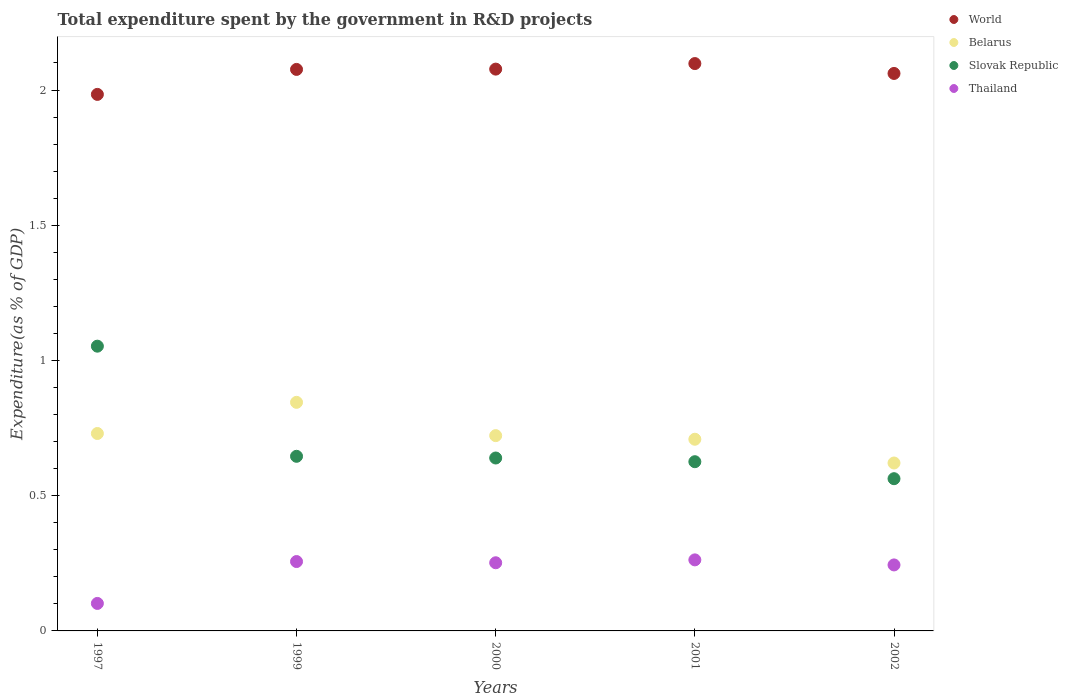What is the total expenditure spent by the government in R&D projects in Thailand in 2002?
Your answer should be very brief. 0.24. Across all years, what is the maximum total expenditure spent by the government in R&D projects in Slovak Republic?
Ensure brevity in your answer.  1.05. Across all years, what is the minimum total expenditure spent by the government in R&D projects in Thailand?
Offer a very short reply. 0.1. In which year was the total expenditure spent by the government in R&D projects in World maximum?
Provide a succinct answer. 2001. What is the total total expenditure spent by the government in R&D projects in World in the graph?
Keep it short and to the point. 10.3. What is the difference between the total expenditure spent by the government in R&D projects in Slovak Republic in 1997 and that in 2000?
Your answer should be very brief. 0.41. What is the difference between the total expenditure spent by the government in R&D projects in Slovak Republic in 2002 and the total expenditure spent by the government in R&D projects in Thailand in 1997?
Ensure brevity in your answer.  0.46. What is the average total expenditure spent by the government in R&D projects in Thailand per year?
Offer a terse response. 0.22. In the year 2000, what is the difference between the total expenditure spent by the government in R&D projects in Belarus and total expenditure spent by the government in R&D projects in Thailand?
Your answer should be compact. 0.47. What is the ratio of the total expenditure spent by the government in R&D projects in Slovak Republic in 1999 to that in 2000?
Give a very brief answer. 1.01. Is the total expenditure spent by the government in R&D projects in Thailand in 1997 less than that in 1999?
Provide a short and direct response. Yes. Is the difference between the total expenditure spent by the government in R&D projects in Belarus in 1999 and 2002 greater than the difference between the total expenditure spent by the government in R&D projects in Thailand in 1999 and 2002?
Ensure brevity in your answer.  Yes. What is the difference between the highest and the second highest total expenditure spent by the government in R&D projects in Thailand?
Provide a succinct answer. 0.01. What is the difference between the highest and the lowest total expenditure spent by the government in R&D projects in World?
Provide a succinct answer. 0.11. In how many years, is the total expenditure spent by the government in R&D projects in Thailand greater than the average total expenditure spent by the government in R&D projects in Thailand taken over all years?
Offer a terse response. 4. Is the sum of the total expenditure spent by the government in R&D projects in World in 1999 and 2001 greater than the maximum total expenditure spent by the government in R&D projects in Thailand across all years?
Give a very brief answer. Yes. Does the total expenditure spent by the government in R&D projects in Slovak Republic monotonically increase over the years?
Give a very brief answer. No. Is the total expenditure spent by the government in R&D projects in Belarus strictly greater than the total expenditure spent by the government in R&D projects in World over the years?
Offer a terse response. No. Is the total expenditure spent by the government in R&D projects in Slovak Republic strictly less than the total expenditure spent by the government in R&D projects in Thailand over the years?
Make the answer very short. No. What is the difference between two consecutive major ticks on the Y-axis?
Your answer should be compact. 0.5. Are the values on the major ticks of Y-axis written in scientific E-notation?
Provide a short and direct response. No. Does the graph contain any zero values?
Your answer should be very brief. No. Where does the legend appear in the graph?
Offer a very short reply. Top right. How many legend labels are there?
Keep it short and to the point. 4. How are the legend labels stacked?
Offer a terse response. Vertical. What is the title of the graph?
Ensure brevity in your answer.  Total expenditure spent by the government in R&D projects. What is the label or title of the X-axis?
Provide a succinct answer. Years. What is the label or title of the Y-axis?
Offer a terse response. Expenditure(as % of GDP). What is the Expenditure(as % of GDP) in World in 1997?
Ensure brevity in your answer.  1.98. What is the Expenditure(as % of GDP) of Belarus in 1997?
Give a very brief answer. 0.73. What is the Expenditure(as % of GDP) of Slovak Republic in 1997?
Your answer should be very brief. 1.05. What is the Expenditure(as % of GDP) in Thailand in 1997?
Your answer should be compact. 0.1. What is the Expenditure(as % of GDP) of World in 1999?
Offer a terse response. 2.08. What is the Expenditure(as % of GDP) in Belarus in 1999?
Provide a short and direct response. 0.85. What is the Expenditure(as % of GDP) in Slovak Republic in 1999?
Ensure brevity in your answer.  0.65. What is the Expenditure(as % of GDP) of Thailand in 1999?
Provide a succinct answer. 0.26. What is the Expenditure(as % of GDP) of World in 2000?
Offer a terse response. 2.08. What is the Expenditure(as % of GDP) in Belarus in 2000?
Provide a succinct answer. 0.72. What is the Expenditure(as % of GDP) in Slovak Republic in 2000?
Your answer should be very brief. 0.64. What is the Expenditure(as % of GDP) in Thailand in 2000?
Ensure brevity in your answer.  0.25. What is the Expenditure(as % of GDP) in World in 2001?
Your answer should be compact. 2.1. What is the Expenditure(as % of GDP) of Belarus in 2001?
Offer a very short reply. 0.71. What is the Expenditure(as % of GDP) of Slovak Republic in 2001?
Your answer should be compact. 0.63. What is the Expenditure(as % of GDP) in Thailand in 2001?
Keep it short and to the point. 0.26. What is the Expenditure(as % of GDP) of World in 2002?
Your response must be concise. 2.06. What is the Expenditure(as % of GDP) of Belarus in 2002?
Make the answer very short. 0.62. What is the Expenditure(as % of GDP) in Slovak Republic in 2002?
Your response must be concise. 0.56. What is the Expenditure(as % of GDP) in Thailand in 2002?
Provide a short and direct response. 0.24. Across all years, what is the maximum Expenditure(as % of GDP) of World?
Your response must be concise. 2.1. Across all years, what is the maximum Expenditure(as % of GDP) of Belarus?
Offer a terse response. 0.85. Across all years, what is the maximum Expenditure(as % of GDP) in Slovak Republic?
Offer a terse response. 1.05. Across all years, what is the maximum Expenditure(as % of GDP) of Thailand?
Your answer should be compact. 0.26. Across all years, what is the minimum Expenditure(as % of GDP) in World?
Your answer should be compact. 1.98. Across all years, what is the minimum Expenditure(as % of GDP) of Belarus?
Offer a very short reply. 0.62. Across all years, what is the minimum Expenditure(as % of GDP) in Slovak Republic?
Ensure brevity in your answer.  0.56. Across all years, what is the minimum Expenditure(as % of GDP) of Thailand?
Your answer should be very brief. 0.1. What is the total Expenditure(as % of GDP) of World in the graph?
Offer a very short reply. 10.3. What is the total Expenditure(as % of GDP) in Belarus in the graph?
Keep it short and to the point. 3.63. What is the total Expenditure(as % of GDP) of Slovak Republic in the graph?
Keep it short and to the point. 3.53. What is the total Expenditure(as % of GDP) in Thailand in the graph?
Make the answer very short. 1.12. What is the difference between the Expenditure(as % of GDP) of World in 1997 and that in 1999?
Offer a terse response. -0.09. What is the difference between the Expenditure(as % of GDP) of Belarus in 1997 and that in 1999?
Provide a succinct answer. -0.12. What is the difference between the Expenditure(as % of GDP) in Slovak Republic in 1997 and that in 1999?
Ensure brevity in your answer.  0.41. What is the difference between the Expenditure(as % of GDP) in Thailand in 1997 and that in 1999?
Your answer should be compact. -0.15. What is the difference between the Expenditure(as % of GDP) in World in 1997 and that in 2000?
Keep it short and to the point. -0.09. What is the difference between the Expenditure(as % of GDP) in Belarus in 1997 and that in 2000?
Give a very brief answer. 0.01. What is the difference between the Expenditure(as % of GDP) of Slovak Republic in 1997 and that in 2000?
Ensure brevity in your answer.  0.41. What is the difference between the Expenditure(as % of GDP) of Thailand in 1997 and that in 2000?
Offer a very short reply. -0.15. What is the difference between the Expenditure(as % of GDP) in World in 1997 and that in 2001?
Offer a very short reply. -0.11. What is the difference between the Expenditure(as % of GDP) of Belarus in 1997 and that in 2001?
Your response must be concise. 0.02. What is the difference between the Expenditure(as % of GDP) in Slovak Republic in 1997 and that in 2001?
Offer a very short reply. 0.43. What is the difference between the Expenditure(as % of GDP) of Thailand in 1997 and that in 2001?
Your response must be concise. -0.16. What is the difference between the Expenditure(as % of GDP) in World in 1997 and that in 2002?
Your answer should be very brief. -0.08. What is the difference between the Expenditure(as % of GDP) of Belarus in 1997 and that in 2002?
Your response must be concise. 0.11. What is the difference between the Expenditure(as % of GDP) of Slovak Republic in 1997 and that in 2002?
Offer a terse response. 0.49. What is the difference between the Expenditure(as % of GDP) in Thailand in 1997 and that in 2002?
Offer a very short reply. -0.14. What is the difference between the Expenditure(as % of GDP) of World in 1999 and that in 2000?
Ensure brevity in your answer.  -0. What is the difference between the Expenditure(as % of GDP) in Belarus in 1999 and that in 2000?
Make the answer very short. 0.12. What is the difference between the Expenditure(as % of GDP) of Slovak Republic in 1999 and that in 2000?
Make the answer very short. 0.01. What is the difference between the Expenditure(as % of GDP) of Thailand in 1999 and that in 2000?
Offer a very short reply. 0. What is the difference between the Expenditure(as % of GDP) in World in 1999 and that in 2001?
Keep it short and to the point. -0.02. What is the difference between the Expenditure(as % of GDP) of Belarus in 1999 and that in 2001?
Keep it short and to the point. 0.14. What is the difference between the Expenditure(as % of GDP) in Slovak Republic in 1999 and that in 2001?
Provide a succinct answer. 0.02. What is the difference between the Expenditure(as % of GDP) in Thailand in 1999 and that in 2001?
Your answer should be very brief. -0.01. What is the difference between the Expenditure(as % of GDP) of World in 1999 and that in 2002?
Provide a short and direct response. 0.01. What is the difference between the Expenditure(as % of GDP) in Belarus in 1999 and that in 2002?
Offer a terse response. 0.22. What is the difference between the Expenditure(as % of GDP) in Slovak Republic in 1999 and that in 2002?
Offer a very short reply. 0.08. What is the difference between the Expenditure(as % of GDP) of Thailand in 1999 and that in 2002?
Offer a very short reply. 0.01. What is the difference between the Expenditure(as % of GDP) of World in 2000 and that in 2001?
Offer a terse response. -0.02. What is the difference between the Expenditure(as % of GDP) of Belarus in 2000 and that in 2001?
Keep it short and to the point. 0.01. What is the difference between the Expenditure(as % of GDP) in Slovak Republic in 2000 and that in 2001?
Ensure brevity in your answer.  0.01. What is the difference between the Expenditure(as % of GDP) of Thailand in 2000 and that in 2001?
Offer a terse response. -0.01. What is the difference between the Expenditure(as % of GDP) of World in 2000 and that in 2002?
Provide a short and direct response. 0.02. What is the difference between the Expenditure(as % of GDP) in Belarus in 2000 and that in 2002?
Ensure brevity in your answer.  0.1. What is the difference between the Expenditure(as % of GDP) in Slovak Republic in 2000 and that in 2002?
Offer a very short reply. 0.08. What is the difference between the Expenditure(as % of GDP) in Thailand in 2000 and that in 2002?
Provide a short and direct response. 0.01. What is the difference between the Expenditure(as % of GDP) of World in 2001 and that in 2002?
Ensure brevity in your answer.  0.04. What is the difference between the Expenditure(as % of GDP) in Belarus in 2001 and that in 2002?
Offer a very short reply. 0.09. What is the difference between the Expenditure(as % of GDP) of Slovak Republic in 2001 and that in 2002?
Your response must be concise. 0.06. What is the difference between the Expenditure(as % of GDP) in Thailand in 2001 and that in 2002?
Make the answer very short. 0.02. What is the difference between the Expenditure(as % of GDP) in World in 1997 and the Expenditure(as % of GDP) in Belarus in 1999?
Your answer should be compact. 1.14. What is the difference between the Expenditure(as % of GDP) of World in 1997 and the Expenditure(as % of GDP) of Slovak Republic in 1999?
Offer a terse response. 1.34. What is the difference between the Expenditure(as % of GDP) of World in 1997 and the Expenditure(as % of GDP) of Thailand in 1999?
Ensure brevity in your answer.  1.73. What is the difference between the Expenditure(as % of GDP) in Belarus in 1997 and the Expenditure(as % of GDP) in Slovak Republic in 1999?
Your answer should be very brief. 0.08. What is the difference between the Expenditure(as % of GDP) in Belarus in 1997 and the Expenditure(as % of GDP) in Thailand in 1999?
Offer a very short reply. 0.47. What is the difference between the Expenditure(as % of GDP) in Slovak Republic in 1997 and the Expenditure(as % of GDP) in Thailand in 1999?
Your answer should be compact. 0.8. What is the difference between the Expenditure(as % of GDP) in World in 1997 and the Expenditure(as % of GDP) in Belarus in 2000?
Provide a succinct answer. 1.26. What is the difference between the Expenditure(as % of GDP) of World in 1997 and the Expenditure(as % of GDP) of Slovak Republic in 2000?
Your response must be concise. 1.34. What is the difference between the Expenditure(as % of GDP) in World in 1997 and the Expenditure(as % of GDP) in Thailand in 2000?
Offer a very short reply. 1.73. What is the difference between the Expenditure(as % of GDP) of Belarus in 1997 and the Expenditure(as % of GDP) of Slovak Republic in 2000?
Your answer should be very brief. 0.09. What is the difference between the Expenditure(as % of GDP) of Belarus in 1997 and the Expenditure(as % of GDP) of Thailand in 2000?
Provide a succinct answer. 0.48. What is the difference between the Expenditure(as % of GDP) of Slovak Republic in 1997 and the Expenditure(as % of GDP) of Thailand in 2000?
Your answer should be compact. 0.8. What is the difference between the Expenditure(as % of GDP) in World in 1997 and the Expenditure(as % of GDP) in Belarus in 2001?
Give a very brief answer. 1.28. What is the difference between the Expenditure(as % of GDP) in World in 1997 and the Expenditure(as % of GDP) in Slovak Republic in 2001?
Make the answer very short. 1.36. What is the difference between the Expenditure(as % of GDP) of World in 1997 and the Expenditure(as % of GDP) of Thailand in 2001?
Ensure brevity in your answer.  1.72. What is the difference between the Expenditure(as % of GDP) of Belarus in 1997 and the Expenditure(as % of GDP) of Slovak Republic in 2001?
Offer a very short reply. 0.1. What is the difference between the Expenditure(as % of GDP) in Belarus in 1997 and the Expenditure(as % of GDP) in Thailand in 2001?
Give a very brief answer. 0.47. What is the difference between the Expenditure(as % of GDP) of Slovak Republic in 1997 and the Expenditure(as % of GDP) of Thailand in 2001?
Provide a short and direct response. 0.79. What is the difference between the Expenditure(as % of GDP) in World in 1997 and the Expenditure(as % of GDP) in Belarus in 2002?
Make the answer very short. 1.36. What is the difference between the Expenditure(as % of GDP) in World in 1997 and the Expenditure(as % of GDP) in Slovak Republic in 2002?
Your response must be concise. 1.42. What is the difference between the Expenditure(as % of GDP) of World in 1997 and the Expenditure(as % of GDP) of Thailand in 2002?
Your response must be concise. 1.74. What is the difference between the Expenditure(as % of GDP) in Belarus in 1997 and the Expenditure(as % of GDP) in Slovak Republic in 2002?
Your response must be concise. 0.17. What is the difference between the Expenditure(as % of GDP) in Belarus in 1997 and the Expenditure(as % of GDP) in Thailand in 2002?
Ensure brevity in your answer.  0.49. What is the difference between the Expenditure(as % of GDP) in Slovak Republic in 1997 and the Expenditure(as % of GDP) in Thailand in 2002?
Offer a terse response. 0.81. What is the difference between the Expenditure(as % of GDP) of World in 1999 and the Expenditure(as % of GDP) of Belarus in 2000?
Offer a terse response. 1.35. What is the difference between the Expenditure(as % of GDP) of World in 1999 and the Expenditure(as % of GDP) of Slovak Republic in 2000?
Keep it short and to the point. 1.44. What is the difference between the Expenditure(as % of GDP) in World in 1999 and the Expenditure(as % of GDP) in Thailand in 2000?
Offer a terse response. 1.82. What is the difference between the Expenditure(as % of GDP) of Belarus in 1999 and the Expenditure(as % of GDP) of Slovak Republic in 2000?
Provide a short and direct response. 0.21. What is the difference between the Expenditure(as % of GDP) of Belarus in 1999 and the Expenditure(as % of GDP) of Thailand in 2000?
Provide a short and direct response. 0.59. What is the difference between the Expenditure(as % of GDP) of Slovak Republic in 1999 and the Expenditure(as % of GDP) of Thailand in 2000?
Provide a succinct answer. 0.39. What is the difference between the Expenditure(as % of GDP) of World in 1999 and the Expenditure(as % of GDP) of Belarus in 2001?
Offer a very short reply. 1.37. What is the difference between the Expenditure(as % of GDP) of World in 1999 and the Expenditure(as % of GDP) of Slovak Republic in 2001?
Offer a terse response. 1.45. What is the difference between the Expenditure(as % of GDP) of World in 1999 and the Expenditure(as % of GDP) of Thailand in 2001?
Ensure brevity in your answer.  1.81. What is the difference between the Expenditure(as % of GDP) of Belarus in 1999 and the Expenditure(as % of GDP) of Slovak Republic in 2001?
Give a very brief answer. 0.22. What is the difference between the Expenditure(as % of GDP) in Belarus in 1999 and the Expenditure(as % of GDP) in Thailand in 2001?
Offer a very short reply. 0.58. What is the difference between the Expenditure(as % of GDP) in Slovak Republic in 1999 and the Expenditure(as % of GDP) in Thailand in 2001?
Your answer should be compact. 0.38. What is the difference between the Expenditure(as % of GDP) of World in 1999 and the Expenditure(as % of GDP) of Belarus in 2002?
Offer a very short reply. 1.46. What is the difference between the Expenditure(as % of GDP) of World in 1999 and the Expenditure(as % of GDP) of Slovak Republic in 2002?
Offer a very short reply. 1.51. What is the difference between the Expenditure(as % of GDP) in World in 1999 and the Expenditure(as % of GDP) in Thailand in 2002?
Give a very brief answer. 1.83. What is the difference between the Expenditure(as % of GDP) in Belarus in 1999 and the Expenditure(as % of GDP) in Slovak Republic in 2002?
Provide a short and direct response. 0.28. What is the difference between the Expenditure(as % of GDP) in Belarus in 1999 and the Expenditure(as % of GDP) in Thailand in 2002?
Keep it short and to the point. 0.6. What is the difference between the Expenditure(as % of GDP) of Slovak Republic in 1999 and the Expenditure(as % of GDP) of Thailand in 2002?
Your answer should be very brief. 0.4. What is the difference between the Expenditure(as % of GDP) of World in 2000 and the Expenditure(as % of GDP) of Belarus in 2001?
Make the answer very short. 1.37. What is the difference between the Expenditure(as % of GDP) in World in 2000 and the Expenditure(as % of GDP) in Slovak Republic in 2001?
Your answer should be compact. 1.45. What is the difference between the Expenditure(as % of GDP) in World in 2000 and the Expenditure(as % of GDP) in Thailand in 2001?
Give a very brief answer. 1.81. What is the difference between the Expenditure(as % of GDP) in Belarus in 2000 and the Expenditure(as % of GDP) in Slovak Republic in 2001?
Your response must be concise. 0.1. What is the difference between the Expenditure(as % of GDP) in Belarus in 2000 and the Expenditure(as % of GDP) in Thailand in 2001?
Offer a terse response. 0.46. What is the difference between the Expenditure(as % of GDP) in Slovak Republic in 2000 and the Expenditure(as % of GDP) in Thailand in 2001?
Give a very brief answer. 0.38. What is the difference between the Expenditure(as % of GDP) in World in 2000 and the Expenditure(as % of GDP) in Belarus in 2002?
Your answer should be very brief. 1.46. What is the difference between the Expenditure(as % of GDP) of World in 2000 and the Expenditure(as % of GDP) of Slovak Republic in 2002?
Make the answer very short. 1.51. What is the difference between the Expenditure(as % of GDP) of World in 2000 and the Expenditure(as % of GDP) of Thailand in 2002?
Offer a very short reply. 1.83. What is the difference between the Expenditure(as % of GDP) of Belarus in 2000 and the Expenditure(as % of GDP) of Slovak Republic in 2002?
Offer a very short reply. 0.16. What is the difference between the Expenditure(as % of GDP) in Belarus in 2000 and the Expenditure(as % of GDP) in Thailand in 2002?
Ensure brevity in your answer.  0.48. What is the difference between the Expenditure(as % of GDP) in Slovak Republic in 2000 and the Expenditure(as % of GDP) in Thailand in 2002?
Make the answer very short. 0.4. What is the difference between the Expenditure(as % of GDP) in World in 2001 and the Expenditure(as % of GDP) in Belarus in 2002?
Give a very brief answer. 1.48. What is the difference between the Expenditure(as % of GDP) in World in 2001 and the Expenditure(as % of GDP) in Slovak Republic in 2002?
Provide a succinct answer. 1.53. What is the difference between the Expenditure(as % of GDP) in World in 2001 and the Expenditure(as % of GDP) in Thailand in 2002?
Offer a very short reply. 1.85. What is the difference between the Expenditure(as % of GDP) of Belarus in 2001 and the Expenditure(as % of GDP) of Slovak Republic in 2002?
Keep it short and to the point. 0.15. What is the difference between the Expenditure(as % of GDP) of Belarus in 2001 and the Expenditure(as % of GDP) of Thailand in 2002?
Provide a succinct answer. 0.46. What is the difference between the Expenditure(as % of GDP) in Slovak Republic in 2001 and the Expenditure(as % of GDP) in Thailand in 2002?
Offer a terse response. 0.38. What is the average Expenditure(as % of GDP) of World per year?
Offer a very short reply. 2.06. What is the average Expenditure(as % of GDP) in Belarus per year?
Provide a short and direct response. 0.73. What is the average Expenditure(as % of GDP) in Slovak Republic per year?
Make the answer very short. 0.71. What is the average Expenditure(as % of GDP) of Thailand per year?
Your response must be concise. 0.22. In the year 1997, what is the difference between the Expenditure(as % of GDP) of World and Expenditure(as % of GDP) of Belarus?
Offer a terse response. 1.25. In the year 1997, what is the difference between the Expenditure(as % of GDP) of World and Expenditure(as % of GDP) of Thailand?
Give a very brief answer. 1.88. In the year 1997, what is the difference between the Expenditure(as % of GDP) of Belarus and Expenditure(as % of GDP) of Slovak Republic?
Provide a succinct answer. -0.32. In the year 1997, what is the difference between the Expenditure(as % of GDP) of Belarus and Expenditure(as % of GDP) of Thailand?
Keep it short and to the point. 0.63. In the year 1997, what is the difference between the Expenditure(as % of GDP) of Slovak Republic and Expenditure(as % of GDP) of Thailand?
Ensure brevity in your answer.  0.95. In the year 1999, what is the difference between the Expenditure(as % of GDP) of World and Expenditure(as % of GDP) of Belarus?
Offer a terse response. 1.23. In the year 1999, what is the difference between the Expenditure(as % of GDP) of World and Expenditure(as % of GDP) of Slovak Republic?
Keep it short and to the point. 1.43. In the year 1999, what is the difference between the Expenditure(as % of GDP) of World and Expenditure(as % of GDP) of Thailand?
Your answer should be very brief. 1.82. In the year 1999, what is the difference between the Expenditure(as % of GDP) in Belarus and Expenditure(as % of GDP) in Slovak Republic?
Offer a very short reply. 0.2. In the year 1999, what is the difference between the Expenditure(as % of GDP) of Belarus and Expenditure(as % of GDP) of Thailand?
Your answer should be very brief. 0.59. In the year 1999, what is the difference between the Expenditure(as % of GDP) in Slovak Republic and Expenditure(as % of GDP) in Thailand?
Your answer should be compact. 0.39. In the year 2000, what is the difference between the Expenditure(as % of GDP) of World and Expenditure(as % of GDP) of Belarus?
Your answer should be compact. 1.36. In the year 2000, what is the difference between the Expenditure(as % of GDP) in World and Expenditure(as % of GDP) in Slovak Republic?
Provide a succinct answer. 1.44. In the year 2000, what is the difference between the Expenditure(as % of GDP) in World and Expenditure(as % of GDP) in Thailand?
Give a very brief answer. 1.83. In the year 2000, what is the difference between the Expenditure(as % of GDP) of Belarus and Expenditure(as % of GDP) of Slovak Republic?
Ensure brevity in your answer.  0.08. In the year 2000, what is the difference between the Expenditure(as % of GDP) of Belarus and Expenditure(as % of GDP) of Thailand?
Provide a short and direct response. 0.47. In the year 2000, what is the difference between the Expenditure(as % of GDP) in Slovak Republic and Expenditure(as % of GDP) in Thailand?
Give a very brief answer. 0.39. In the year 2001, what is the difference between the Expenditure(as % of GDP) in World and Expenditure(as % of GDP) in Belarus?
Your answer should be very brief. 1.39. In the year 2001, what is the difference between the Expenditure(as % of GDP) in World and Expenditure(as % of GDP) in Slovak Republic?
Provide a short and direct response. 1.47. In the year 2001, what is the difference between the Expenditure(as % of GDP) of World and Expenditure(as % of GDP) of Thailand?
Offer a terse response. 1.84. In the year 2001, what is the difference between the Expenditure(as % of GDP) of Belarus and Expenditure(as % of GDP) of Slovak Republic?
Your response must be concise. 0.08. In the year 2001, what is the difference between the Expenditure(as % of GDP) in Belarus and Expenditure(as % of GDP) in Thailand?
Give a very brief answer. 0.45. In the year 2001, what is the difference between the Expenditure(as % of GDP) in Slovak Republic and Expenditure(as % of GDP) in Thailand?
Offer a terse response. 0.36. In the year 2002, what is the difference between the Expenditure(as % of GDP) in World and Expenditure(as % of GDP) in Belarus?
Provide a succinct answer. 1.44. In the year 2002, what is the difference between the Expenditure(as % of GDP) of World and Expenditure(as % of GDP) of Slovak Republic?
Your answer should be compact. 1.5. In the year 2002, what is the difference between the Expenditure(as % of GDP) in World and Expenditure(as % of GDP) in Thailand?
Your answer should be very brief. 1.82. In the year 2002, what is the difference between the Expenditure(as % of GDP) in Belarus and Expenditure(as % of GDP) in Slovak Republic?
Ensure brevity in your answer.  0.06. In the year 2002, what is the difference between the Expenditure(as % of GDP) of Belarus and Expenditure(as % of GDP) of Thailand?
Provide a short and direct response. 0.38. In the year 2002, what is the difference between the Expenditure(as % of GDP) of Slovak Republic and Expenditure(as % of GDP) of Thailand?
Offer a terse response. 0.32. What is the ratio of the Expenditure(as % of GDP) of World in 1997 to that in 1999?
Your answer should be compact. 0.96. What is the ratio of the Expenditure(as % of GDP) of Belarus in 1997 to that in 1999?
Offer a terse response. 0.86. What is the ratio of the Expenditure(as % of GDP) of Slovak Republic in 1997 to that in 1999?
Your answer should be very brief. 1.63. What is the ratio of the Expenditure(as % of GDP) of Thailand in 1997 to that in 1999?
Make the answer very short. 0.4. What is the ratio of the Expenditure(as % of GDP) of World in 1997 to that in 2000?
Make the answer very short. 0.95. What is the ratio of the Expenditure(as % of GDP) in Belarus in 1997 to that in 2000?
Keep it short and to the point. 1.01. What is the ratio of the Expenditure(as % of GDP) in Slovak Republic in 1997 to that in 2000?
Your answer should be very brief. 1.65. What is the ratio of the Expenditure(as % of GDP) of Thailand in 1997 to that in 2000?
Offer a terse response. 0.4. What is the ratio of the Expenditure(as % of GDP) of World in 1997 to that in 2001?
Provide a short and direct response. 0.95. What is the ratio of the Expenditure(as % of GDP) of Belarus in 1997 to that in 2001?
Give a very brief answer. 1.03. What is the ratio of the Expenditure(as % of GDP) in Slovak Republic in 1997 to that in 2001?
Your response must be concise. 1.68. What is the ratio of the Expenditure(as % of GDP) of Thailand in 1997 to that in 2001?
Your answer should be compact. 0.39. What is the ratio of the Expenditure(as % of GDP) of World in 1997 to that in 2002?
Your response must be concise. 0.96. What is the ratio of the Expenditure(as % of GDP) in Belarus in 1997 to that in 2002?
Your answer should be very brief. 1.18. What is the ratio of the Expenditure(as % of GDP) of Slovak Republic in 1997 to that in 2002?
Ensure brevity in your answer.  1.87. What is the ratio of the Expenditure(as % of GDP) in Thailand in 1997 to that in 2002?
Your answer should be very brief. 0.42. What is the ratio of the Expenditure(as % of GDP) in World in 1999 to that in 2000?
Your response must be concise. 1. What is the ratio of the Expenditure(as % of GDP) of Belarus in 1999 to that in 2000?
Make the answer very short. 1.17. What is the ratio of the Expenditure(as % of GDP) of Slovak Republic in 1999 to that in 2000?
Ensure brevity in your answer.  1.01. What is the ratio of the Expenditure(as % of GDP) of Thailand in 1999 to that in 2000?
Ensure brevity in your answer.  1.02. What is the ratio of the Expenditure(as % of GDP) of World in 1999 to that in 2001?
Ensure brevity in your answer.  0.99. What is the ratio of the Expenditure(as % of GDP) in Belarus in 1999 to that in 2001?
Keep it short and to the point. 1.19. What is the ratio of the Expenditure(as % of GDP) of Slovak Republic in 1999 to that in 2001?
Give a very brief answer. 1.03. What is the ratio of the Expenditure(as % of GDP) in Thailand in 1999 to that in 2001?
Keep it short and to the point. 0.98. What is the ratio of the Expenditure(as % of GDP) of World in 1999 to that in 2002?
Provide a succinct answer. 1.01. What is the ratio of the Expenditure(as % of GDP) of Belarus in 1999 to that in 2002?
Keep it short and to the point. 1.36. What is the ratio of the Expenditure(as % of GDP) of Slovak Republic in 1999 to that in 2002?
Ensure brevity in your answer.  1.15. What is the ratio of the Expenditure(as % of GDP) of Thailand in 1999 to that in 2002?
Your answer should be compact. 1.05. What is the ratio of the Expenditure(as % of GDP) in World in 2000 to that in 2001?
Offer a very short reply. 0.99. What is the ratio of the Expenditure(as % of GDP) of Belarus in 2000 to that in 2001?
Give a very brief answer. 1.02. What is the ratio of the Expenditure(as % of GDP) of Slovak Republic in 2000 to that in 2001?
Provide a succinct answer. 1.02. What is the ratio of the Expenditure(as % of GDP) of Thailand in 2000 to that in 2001?
Provide a short and direct response. 0.96. What is the ratio of the Expenditure(as % of GDP) in World in 2000 to that in 2002?
Your response must be concise. 1.01. What is the ratio of the Expenditure(as % of GDP) in Belarus in 2000 to that in 2002?
Provide a succinct answer. 1.16. What is the ratio of the Expenditure(as % of GDP) of Slovak Republic in 2000 to that in 2002?
Give a very brief answer. 1.14. What is the ratio of the Expenditure(as % of GDP) in Thailand in 2000 to that in 2002?
Provide a short and direct response. 1.03. What is the ratio of the Expenditure(as % of GDP) in World in 2001 to that in 2002?
Provide a short and direct response. 1.02. What is the ratio of the Expenditure(as % of GDP) in Belarus in 2001 to that in 2002?
Provide a short and direct response. 1.14. What is the ratio of the Expenditure(as % of GDP) of Slovak Republic in 2001 to that in 2002?
Ensure brevity in your answer.  1.11. What is the ratio of the Expenditure(as % of GDP) of Thailand in 2001 to that in 2002?
Your answer should be compact. 1.08. What is the difference between the highest and the second highest Expenditure(as % of GDP) of World?
Provide a short and direct response. 0.02. What is the difference between the highest and the second highest Expenditure(as % of GDP) of Belarus?
Ensure brevity in your answer.  0.12. What is the difference between the highest and the second highest Expenditure(as % of GDP) of Slovak Republic?
Provide a succinct answer. 0.41. What is the difference between the highest and the second highest Expenditure(as % of GDP) in Thailand?
Provide a short and direct response. 0.01. What is the difference between the highest and the lowest Expenditure(as % of GDP) in World?
Give a very brief answer. 0.11. What is the difference between the highest and the lowest Expenditure(as % of GDP) of Belarus?
Your answer should be compact. 0.22. What is the difference between the highest and the lowest Expenditure(as % of GDP) in Slovak Republic?
Provide a short and direct response. 0.49. What is the difference between the highest and the lowest Expenditure(as % of GDP) of Thailand?
Your answer should be very brief. 0.16. 